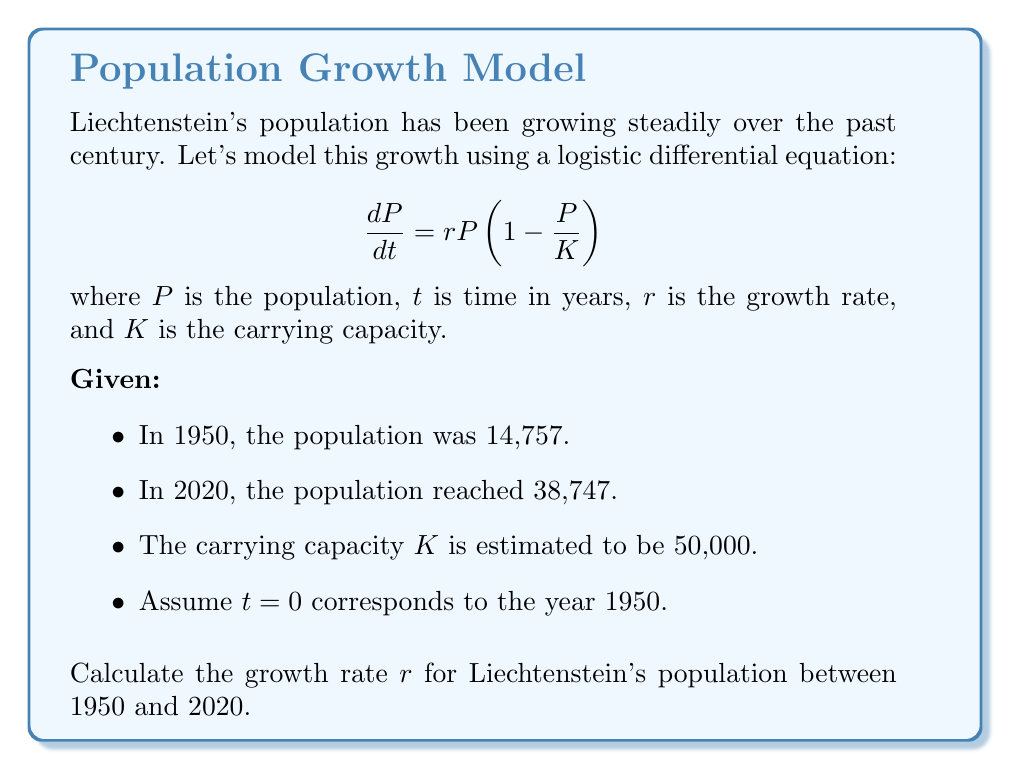What is the answer to this math problem? To solve this problem, we'll use the logistic growth model and the given information:

1) The logistic differential equation is:
   $$\frac{dP}{dt} = rP(1 - \frac{P}{K})$$

2) The solution to this equation is:
   $$P(t) = \frac{K}{1 + (\frac{K}{P_0} - 1)e^{-rt}}$$
   where $P_0$ is the initial population.

3) We know:
   - $P_0 = 14,757$ (population in 1950)
   - $P(70) = 38,747$ (population in 2020, 70 years later)
   - $K = 50,000$ (carrying capacity)

4) Substituting these values into the equation:
   $$38,747 = \frac{50,000}{1 + (\frac{50,000}{14,757} - 1)e^{-70r}}$$

5) Simplify:
   $$38,747 = \frac{50,000}{1 + 2.3882e^{-70r}}$$

6) Solve for $e^{-70r}$:
   $$1 + 2.3882e^{-70r} = \frac{50,000}{38,747}$$
   $$2.3882e^{-70r} = \frac{50,000}{38,747} - 1 = 0.2904$$
   $$e^{-70r} = 0.1216$$

7) Take natural log of both sides:
   $$-70r = \ln(0.1216)$$

8) Solve for $r$:
   $$r = -\frac{\ln(0.1216)}{70} = 0.0304$$

Therefore, the growth rate $r$ is approximately 0.0304 or 3.04% per year.
Answer: $r \approx 0.0304$ 